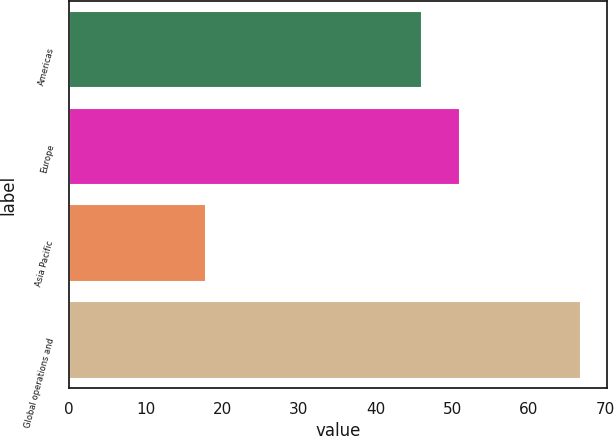Convert chart to OTSL. <chart><loc_0><loc_0><loc_500><loc_500><bar_chart><fcel>Americas<fcel>Europe<fcel>Asia Pacific<fcel>Global operations and<nl><fcel>46.1<fcel>50.99<fcel>17.9<fcel>66.8<nl></chart> 